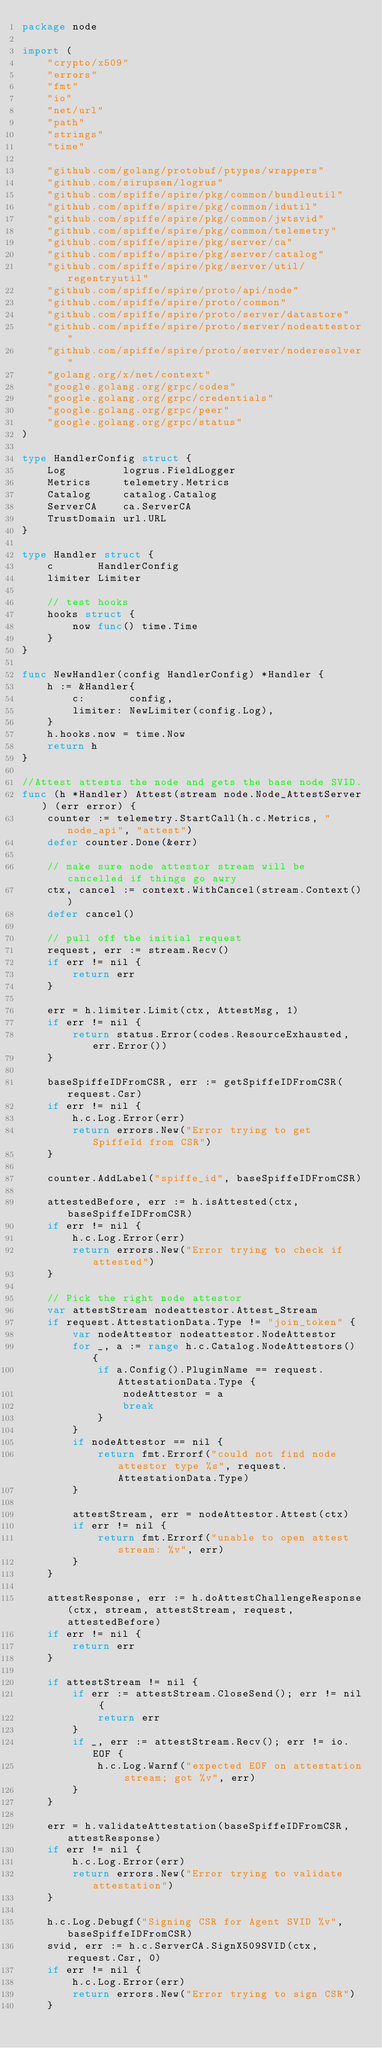<code> <loc_0><loc_0><loc_500><loc_500><_Go_>package node

import (
	"crypto/x509"
	"errors"
	"fmt"
	"io"
	"net/url"
	"path"
	"strings"
	"time"

	"github.com/golang/protobuf/ptypes/wrappers"
	"github.com/sirupsen/logrus"
	"github.com/spiffe/spire/pkg/common/bundleutil"
	"github.com/spiffe/spire/pkg/common/idutil"
	"github.com/spiffe/spire/pkg/common/jwtsvid"
	"github.com/spiffe/spire/pkg/common/telemetry"
	"github.com/spiffe/spire/pkg/server/ca"
	"github.com/spiffe/spire/pkg/server/catalog"
	"github.com/spiffe/spire/pkg/server/util/regentryutil"
	"github.com/spiffe/spire/proto/api/node"
	"github.com/spiffe/spire/proto/common"
	"github.com/spiffe/spire/proto/server/datastore"
	"github.com/spiffe/spire/proto/server/nodeattestor"
	"github.com/spiffe/spire/proto/server/noderesolver"
	"golang.org/x/net/context"
	"google.golang.org/grpc/codes"
	"google.golang.org/grpc/credentials"
	"google.golang.org/grpc/peer"
	"google.golang.org/grpc/status"
)

type HandlerConfig struct {
	Log         logrus.FieldLogger
	Metrics     telemetry.Metrics
	Catalog     catalog.Catalog
	ServerCA    ca.ServerCA
	TrustDomain url.URL
}

type Handler struct {
	c       HandlerConfig
	limiter Limiter

	// test hooks
	hooks struct {
		now func() time.Time
	}
}

func NewHandler(config HandlerConfig) *Handler {
	h := &Handler{
		c:       config,
		limiter: NewLimiter(config.Log),
	}
	h.hooks.now = time.Now
	return h
}

//Attest attests the node and gets the base node SVID.
func (h *Handler) Attest(stream node.Node_AttestServer) (err error) {
	counter := telemetry.StartCall(h.c.Metrics, "node_api", "attest")
	defer counter.Done(&err)

	// make sure node attestor stream will be cancelled if things go awry
	ctx, cancel := context.WithCancel(stream.Context())
	defer cancel()

	// pull off the initial request
	request, err := stream.Recv()
	if err != nil {
		return err
	}

	err = h.limiter.Limit(ctx, AttestMsg, 1)
	if err != nil {
		return status.Error(codes.ResourceExhausted, err.Error())
	}

	baseSpiffeIDFromCSR, err := getSpiffeIDFromCSR(request.Csr)
	if err != nil {
		h.c.Log.Error(err)
		return errors.New("Error trying to get SpiffeId from CSR")
	}

	counter.AddLabel("spiffe_id", baseSpiffeIDFromCSR)

	attestedBefore, err := h.isAttested(ctx, baseSpiffeIDFromCSR)
	if err != nil {
		h.c.Log.Error(err)
		return errors.New("Error trying to check if attested")
	}

	// Pick the right node attestor
	var attestStream nodeattestor.Attest_Stream
	if request.AttestationData.Type != "join_token" {
		var nodeAttestor nodeattestor.NodeAttestor
		for _, a := range h.c.Catalog.NodeAttestors() {
			if a.Config().PluginName == request.AttestationData.Type {
				nodeAttestor = a
				break
			}
		}
		if nodeAttestor == nil {
			return fmt.Errorf("could not find node attestor type %s", request.AttestationData.Type)
		}

		attestStream, err = nodeAttestor.Attest(ctx)
		if err != nil {
			return fmt.Errorf("unable to open attest stream: %v", err)
		}
	}

	attestResponse, err := h.doAttestChallengeResponse(ctx, stream, attestStream, request, attestedBefore)
	if err != nil {
		return err
	}

	if attestStream != nil {
		if err := attestStream.CloseSend(); err != nil {
			return err
		}
		if _, err := attestStream.Recv(); err != io.EOF {
			h.c.Log.Warnf("expected EOF on attestation stream; got %v", err)
		}
	}

	err = h.validateAttestation(baseSpiffeIDFromCSR, attestResponse)
	if err != nil {
		h.c.Log.Error(err)
		return errors.New("Error trying to validate attestation")
	}

	h.c.Log.Debugf("Signing CSR for Agent SVID %v", baseSpiffeIDFromCSR)
	svid, err := h.c.ServerCA.SignX509SVID(ctx, request.Csr, 0)
	if err != nil {
		h.c.Log.Error(err)
		return errors.New("Error trying to sign CSR")
	}
</code> 